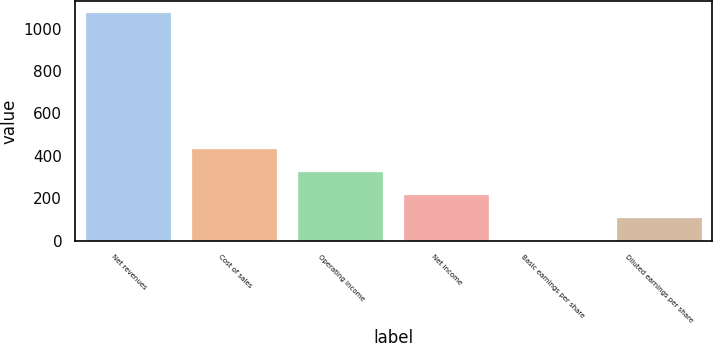Convert chart. <chart><loc_0><loc_0><loc_500><loc_500><bar_chart><fcel>Net revenues<fcel>Cost of sales<fcel>Operating income<fcel>Net income<fcel>Basic earnings per share<fcel>Diluted earnings per share<nl><fcel>1075<fcel>430.08<fcel>322.6<fcel>215.12<fcel>0.16<fcel>107.64<nl></chart> 